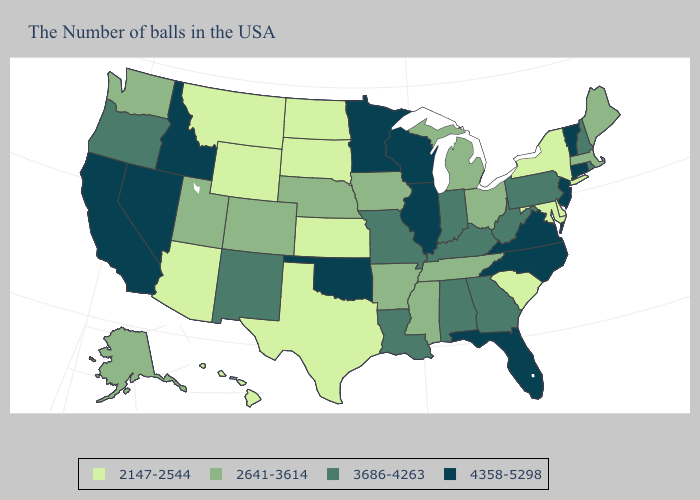Does Connecticut have the highest value in the Northeast?
Concise answer only. Yes. What is the lowest value in the USA?
Concise answer only. 2147-2544. What is the value of Missouri?
Concise answer only. 3686-4263. What is the highest value in the South ?
Concise answer only. 4358-5298. Name the states that have a value in the range 3686-4263?
Be succinct. Rhode Island, New Hampshire, Pennsylvania, West Virginia, Georgia, Kentucky, Indiana, Alabama, Louisiana, Missouri, New Mexico, Oregon. Name the states that have a value in the range 2147-2544?
Answer briefly. New York, Delaware, Maryland, South Carolina, Kansas, Texas, South Dakota, North Dakota, Wyoming, Montana, Arizona, Hawaii. Name the states that have a value in the range 4358-5298?
Be succinct. Vermont, Connecticut, New Jersey, Virginia, North Carolina, Florida, Wisconsin, Illinois, Minnesota, Oklahoma, Idaho, Nevada, California. Which states hav the highest value in the South?
Short answer required. Virginia, North Carolina, Florida, Oklahoma. What is the value of Arizona?
Be succinct. 2147-2544. What is the value of Idaho?
Keep it brief. 4358-5298. Name the states that have a value in the range 3686-4263?
Quick response, please. Rhode Island, New Hampshire, Pennsylvania, West Virginia, Georgia, Kentucky, Indiana, Alabama, Louisiana, Missouri, New Mexico, Oregon. What is the lowest value in the USA?
Answer briefly. 2147-2544. Name the states that have a value in the range 2641-3614?
Give a very brief answer. Maine, Massachusetts, Ohio, Michigan, Tennessee, Mississippi, Arkansas, Iowa, Nebraska, Colorado, Utah, Washington, Alaska. What is the value of Kansas?
Keep it brief. 2147-2544. What is the value of Florida?
Concise answer only. 4358-5298. 